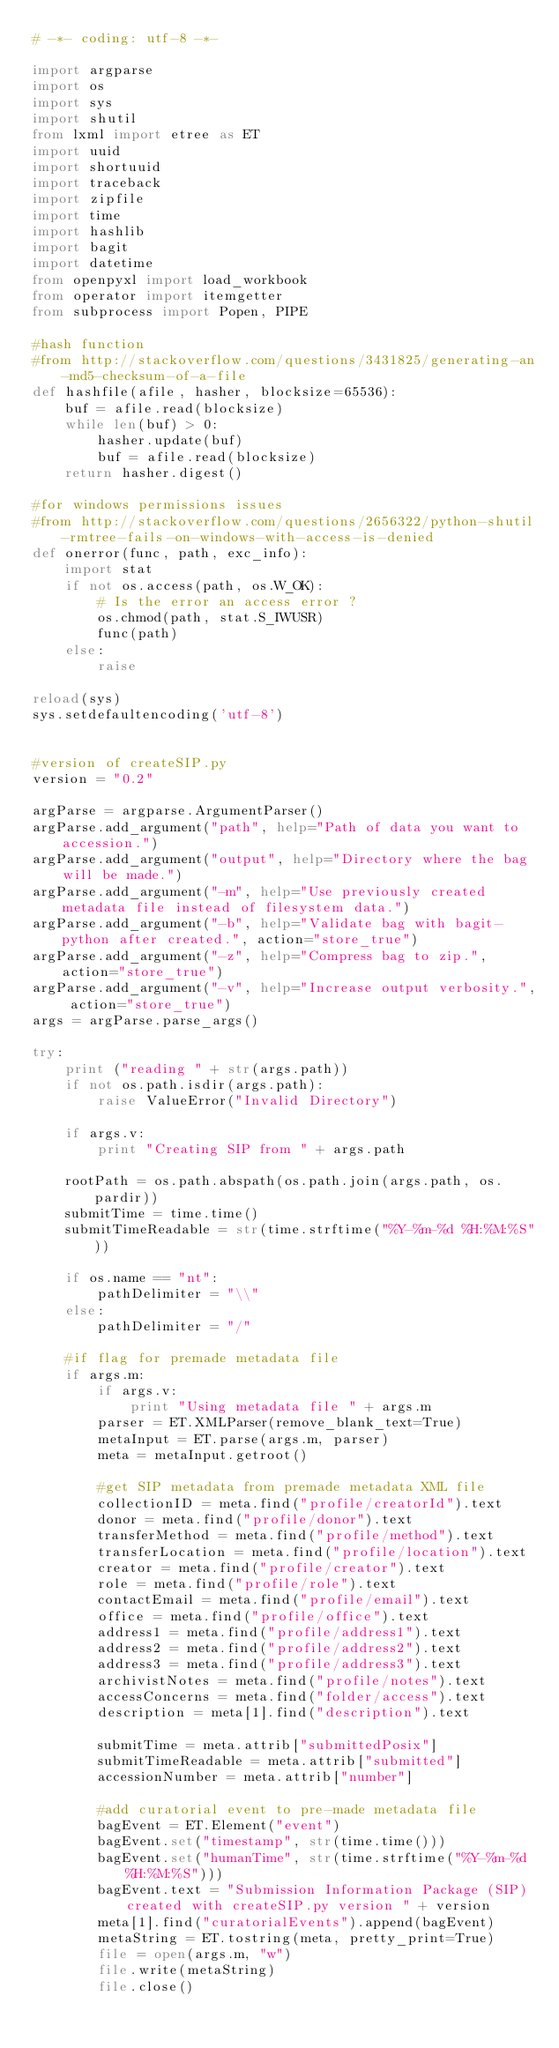Convert code to text. <code><loc_0><loc_0><loc_500><loc_500><_Python_># -*- coding: utf-8 -*-

import argparse
import os
import sys
import shutil
from lxml import etree as ET
import uuid
import shortuuid
import traceback
import zipfile
import time
import hashlib
import bagit
import datetime
from openpyxl import load_workbook
from operator import itemgetter
from subprocess import Popen, PIPE

#hash function
#from http://stackoverflow.com/questions/3431825/generating-an-md5-checksum-of-a-file
def hashfile(afile, hasher, blocksize=65536):
    buf = afile.read(blocksize)
    while len(buf) > 0:
        hasher.update(buf)
        buf = afile.read(blocksize)
    return hasher.digest()

#for windows permissions issues
#from http://stackoverflow.com/questions/2656322/python-shutil-rmtree-fails-on-windows-with-access-is-denied
def onerror(func, path, exc_info):
	import stat
	if not os.access(path, os.W_OK):
		# Is the error an access error ?
		os.chmod(path, stat.S_IWUSR)
		func(path)
	else:
		raise
	
reload(sys)
sys.setdefaultencoding('utf-8')


#version of createSIP.py
version = "0.2"
	
argParse = argparse.ArgumentParser()
argParse.add_argument("path", help="Path of data you want to accession.")
argParse.add_argument("output", help="Directory where the bag will be made.")
argParse.add_argument("-m", help="Use previously created metadata file instead of filesystem data.")
argParse.add_argument("-b", help="Validate bag with bagit-python after created.", action="store_true")
argParse.add_argument("-z", help="Compress bag to zip.", action="store_true")
argParse.add_argument("-v", help="Increase output verbosity.", action="store_true")
args = argParse.parse_args()

try:
	print ("reading " + str(args.path))
	if not os.path.isdir(args.path):
		raise ValueError("Invalid Directory")

	if args.v:
	    print "Creating SIP from " + args.path

	rootPath = os.path.abspath(os.path.join(args.path, os.pardir))
	submitTime = time.time()
	submitTimeReadable = str(time.strftime("%Y-%m-%d %H:%M:%S"))

	if os.name == "nt":
		pathDelimiter = "\\"
	else:
		pathDelimiter = "/"
		
	#if flag for premade metadata file
	if args.m:
		if args.v:
			print "Using metadata file " + args.m
		parser = ET.XMLParser(remove_blank_text=True)
		metaInput = ET.parse(args.m, parser)
		meta = metaInput.getroot()

		#get SIP metadata from premade metadata XML file
		collectionID = meta.find("profile/creatorId").text
		donor = meta.find("profile/donor").text
		transferMethod = meta.find("profile/method").text
		transferLocation = meta.find("profile/location").text
		creator = meta.find("profile/creator").text
		role = meta.find("profile/role").text
		contactEmail = meta.find("profile/email").text
		office = meta.find("profile/office").text
		address1 = meta.find("profile/address1").text
		address2 = meta.find("profile/address2").text
		address3 = meta.find("profile/address3").text
		archivistNotes = meta.find("profile/notes").text
		accessConcerns = meta.find("folder/access").text
		description = meta[1].find("description").text

		submitTime = meta.attrib["submittedPosix"]
		submitTimeReadable = meta.attrib["submitted"]
		accessionNumber = meta.attrib["number"]
		
		#add curatorial event to pre-made metadata file
		bagEvent = ET.Element("event")
		bagEvent.set("timestamp", str(time.time()))
		bagEvent.set("humanTime", str(time.strftime("%Y-%m-%d %H:%M:%S")))
		bagEvent.text = "Submission Information Package (SIP) created with createSIP.py version " + version
		meta[1].find("curatorialEvents").append(bagEvent)
		metaString = ET.tostring(meta, pretty_print=True)
		file = open(args.m, "w")
		file.write(metaString)
		file.close()
</code> 